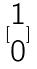Convert formula to latex. <formula><loc_0><loc_0><loc_500><loc_500>[ \begin{matrix} 1 \\ 0 \end{matrix} ]</formula> 